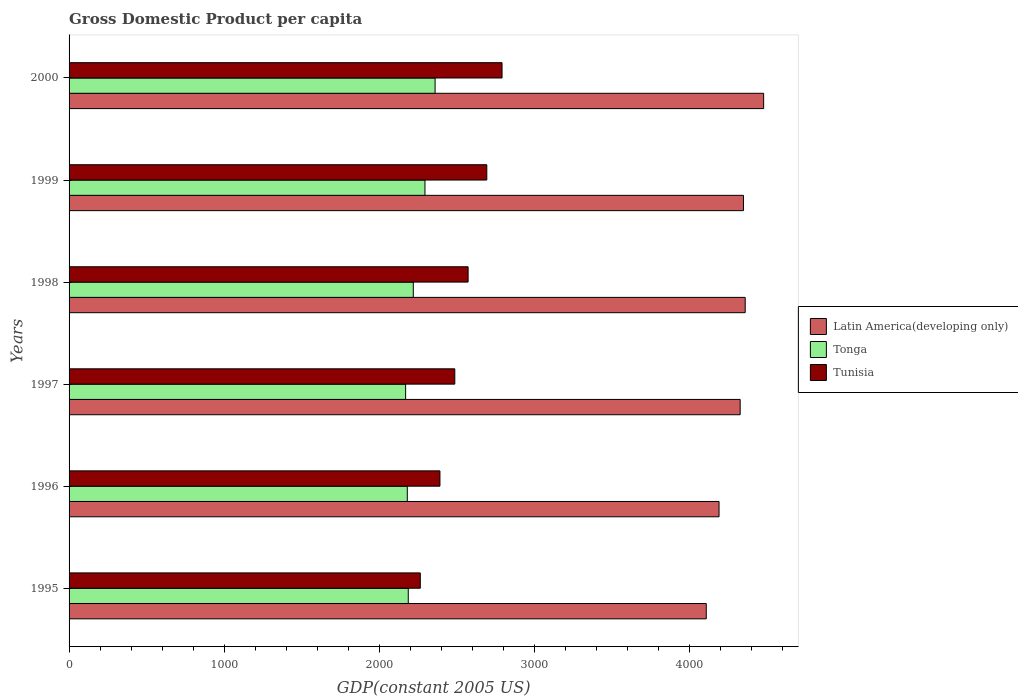How many groups of bars are there?
Give a very brief answer. 6. Are the number of bars on each tick of the Y-axis equal?
Offer a terse response. Yes. How many bars are there on the 4th tick from the top?
Provide a short and direct response. 3. In how many cases, is the number of bars for a given year not equal to the number of legend labels?
Make the answer very short. 0. What is the GDP per capita in Tunisia in 2000?
Your answer should be very brief. 2790.77. Across all years, what is the maximum GDP per capita in Latin America(developing only)?
Offer a very short reply. 4476.93. Across all years, what is the minimum GDP per capita in Tonga?
Give a very brief answer. 2169.26. What is the total GDP per capita in Latin America(developing only) in the graph?
Give a very brief answer. 2.58e+04. What is the difference between the GDP per capita in Tonga in 1996 and that in 1999?
Give a very brief answer. -113.94. What is the difference between the GDP per capita in Tonga in 1996 and the GDP per capita in Latin America(developing only) in 2000?
Provide a succinct answer. -2296.86. What is the average GDP per capita in Latin America(developing only) per year?
Your response must be concise. 4300.7. In the year 1997, what is the difference between the GDP per capita in Tunisia and GDP per capita in Tonga?
Provide a succinct answer. 316.95. What is the ratio of the GDP per capita in Latin America(developing only) in 1996 to that in 1997?
Your response must be concise. 0.97. Is the GDP per capita in Latin America(developing only) in 1997 less than that in 1998?
Ensure brevity in your answer.  Yes. What is the difference between the highest and the second highest GDP per capita in Tunisia?
Keep it short and to the point. 98.3. What is the difference between the highest and the lowest GDP per capita in Latin America(developing only)?
Your answer should be compact. 369.84. In how many years, is the GDP per capita in Tunisia greater than the average GDP per capita in Tunisia taken over all years?
Offer a terse response. 3. What does the 3rd bar from the top in 1997 represents?
Offer a very short reply. Latin America(developing only). What does the 2nd bar from the bottom in 1997 represents?
Provide a succinct answer. Tonga. How many bars are there?
Give a very brief answer. 18. What is the difference between two consecutive major ticks on the X-axis?
Give a very brief answer. 1000. Are the values on the major ticks of X-axis written in scientific E-notation?
Keep it short and to the point. No. How are the legend labels stacked?
Offer a terse response. Vertical. What is the title of the graph?
Provide a succinct answer. Gross Domestic Product per capita. What is the label or title of the X-axis?
Your answer should be compact. GDP(constant 2005 US). What is the label or title of the Y-axis?
Offer a terse response. Years. What is the GDP(constant 2005 US) in Latin America(developing only) in 1995?
Make the answer very short. 4107.09. What is the GDP(constant 2005 US) of Tonga in 1995?
Your answer should be very brief. 2186.32. What is the GDP(constant 2005 US) in Tunisia in 1995?
Provide a succinct answer. 2263.9. What is the GDP(constant 2005 US) in Latin America(developing only) in 1996?
Make the answer very short. 4189.51. What is the GDP(constant 2005 US) of Tonga in 1996?
Give a very brief answer. 2180.07. What is the GDP(constant 2005 US) of Tunisia in 1996?
Provide a short and direct response. 2390.5. What is the GDP(constant 2005 US) in Latin America(developing only) in 1997?
Make the answer very short. 4325.7. What is the GDP(constant 2005 US) of Tonga in 1997?
Provide a short and direct response. 2169.26. What is the GDP(constant 2005 US) in Tunisia in 1997?
Your response must be concise. 2486.21. What is the GDP(constant 2005 US) in Latin America(developing only) in 1998?
Provide a short and direct response. 4358.09. What is the GDP(constant 2005 US) in Tonga in 1998?
Your answer should be very brief. 2218.79. What is the GDP(constant 2005 US) in Tunisia in 1998?
Your answer should be compact. 2572.1. What is the GDP(constant 2005 US) of Latin America(developing only) in 1999?
Ensure brevity in your answer.  4346.88. What is the GDP(constant 2005 US) of Tonga in 1999?
Offer a terse response. 2294.01. What is the GDP(constant 2005 US) of Tunisia in 1999?
Offer a terse response. 2692.46. What is the GDP(constant 2005 US) in Latin America(developing only) in 2000?
Provide a short and direct response. 4476.93. What is the GDP(constant 2005 US) in Tonga in 2000?
Offer a very short reply. 2359.2. What is the GDP(constant 2005 US) of Tunisia in 2000?
Ensure brevity in your answer.  2790.77. Across all years, what is the maximum GDP(constant 2005 US) in Latin America(developing only)?
Ensure brevity in your answer.  4476.93. Across all years, what is the maximum GDP(constant 2005 US) of Tonga?
Your answer should be very brief. 2359.2. Across all years, what is the maximum GDP(constant 2005 US) in Tunisia?
Your response must be concise. 2790.77. Across all years, what is the minimum GDP(constant 2005 US) of Latin America(developing only)?
Ensure brevity in your answer.  4107.09. Across all years, what is the minimum GDP(constant 2005 US) in Tonga?
Your answer should be compact. 2169.26. Across all years, what is the minimum GDP(constant 2005 US) in Tunisia?
Offer a very short reply. 2263.9. What is the total GDP(constant 2005 US) of Latin America(developing only) in the graph?
Give a very brief answer. 2.58e+04. What is the total GDP(constant 2005 US) of Tonga in the graph?
Offer a very short reply. 1.34e+04. What is the total GDP(constant 2005 US) of Tunisia in the graph?
Provide a succinct answer. 1.52e+04. What is the difference between the GDP(constant 2005 US) of Latin America(developing only) in 1995 and that in 1996?
Give a very brief answer. -82.41. What is the difference between the GDP(constant 2005 US) in Tonga in 1995 and that in 1996?
Offer a very short reply. 6.26. What is the difference between the GDP(constant 2005 US) in Tunisia in 1995 and that in 1996?
Ensure brevity in your answer.  -126.61. What is the difference between the GDP(constant 2005 US) in Latin America(developing only) in 1995 and that in 1997?
Your answer should be very brief. -218.61. What is the difference between the GDP(constant 2005 US) of Tonga in 1995 and that in 1997?
Provide a short and direct response. 17.06. What is the difference between the GDP(constant 2005 US) of Tunisia in 1995 and that in 1997?
Make the answer very short. -222.32. What is the difference between the GDP(constant 2005 US) in Latin America(developing only) in 1995 and that in 1998?
Your response must be concise. -251. What is the difference between the GDP(constant 2005 US) of Tonga in 1995 and that in 1998?
Provide a short and direct response. -32.47. What is the difference between the GDP(constant 2005 US) of Tunisia in 1995 and that in 1998?
Offer a terse response. -308.2. What is the difference between the GDP(constant 2005 US) in Latin America(developing only) in 1995 and that in 1999?
Give a very brief answer. -239.78. What is the difference between the GDP(constant 2005 US) of Tonga in 1995 and that in 1999?
Make the answer very short. -107.68. What is the difference between the GDP(constant 2005 US) in Tunisia in 1995 and that in 1999?
Your response must be concise. -428.57. What is the difference between the GDP(constant 2005 US) of Latin America(developing only) in 1995 and that in 2000?
Ensure brevity in your answer.  -369.84. What is the difference between the GDP(constant 2005 US) of Tonga in 1995 and that in 2000?
Give a very brief answer. -172.88. What is the difference between the GDP(constant 2005 US) of Tunisia in 1995 and that in 2000?
Provide a succinct answer. -526.87. What is the difference between the GDP(constant 2005 US) of Latin America(developing only) in 1996 and that in 1997?
Keep it short and to the point. -136.19. What is the difference between the GDP(constant 2005 US) in Tonga in 1996 and that in 1997?
Your answer should be compact. 10.81. What is the difference between the GDP(constant 2005 US) of Tunisia in 1996 and that in 1997?
Make the answer very short. -95.71. What is the difference between the GDP(constant 2005 US) in Latin America(developing only) in 1996 and that in 1998?
Provide a succinct answer. -168.58. What is the difference between the GDP(constant 2005 US) in Tonga in 1996 and that in 1998?
Provide a succinct answer. -38.72. What is the difference between the GDP(constant 2005 US) in Tunisia in 1996 and that in 1998?
Give a very brief answer. -181.6. What is the difference between the GDP(constant 2005 US) in Latin America(developing only) in 1996 and that in 1999?
Your response must be concise. -157.37. What is the difference between the GDP(constant 2005 US) in Tonga in 1996 and that in 1999?
Offer a terse response. -113.94. What is the difference between the GDP(constant 2005 US) of Tunisia in 1996 and that in 1999?
Your answer should be compact. -301.96. What is the difference between the GDP(constant 2005 US) in Latin America(developing only) in 1996 and that in 2000?
Your answer should be compact. -287.43. What is the difference between the GDP(constant 2005 US) in Tonga in 1996 and that in 2000?
Make the answer very short. -179.13. What is the difference between the GDP(constant 2005 US) of Tunisia in 1996 and that in 2000?
Provide a succinct answer. -400.26. What is the difference between the GDP(constant 2005 US) in Latin America(developing only) in 1997 and that in 1998?
Give a very brief answer. -32.39. What is the difference between the GDP(constant 2005 US) in Tonga in 1997 and that in 1998?
Your answer should be very brief. -49.53. What is the difference between the GDP(constant 2005 US) of Tunisia in 1997 and that in 1998?
Provide a succinct answer. -85.89. What is the difference between the GDP(constant 2005 US) in Latin America(developing only) in 1997 and that in 1999?
Ensure brevity in your answer.  -21.17. What is the difference between the GDP(constant 2005 US) in Tonga in 1997 and that in 1999?
Your answer should be very brief. -124.75. What is the difference between the GDP(constant 2005 US) of Tunisia in 1997 and that in 1999?
Provide a succinct answer. -206.25. What is the difference between the GDP(constant 2005 US) of Latin America(developing only) in 1997 and that in 2000?
Offer a terse response. -151.23. What is the difference between the GDP(constant 2005 US) of Tonga in 1997 and that in 2000?
Keep it short and to the point. -189.94. What is the difference between the GDP(constant 2005 US) of Tunisia in 1997 and that in 2000?
Offer a terse response. -304.55. What is the difference between the GDP(constant 2005 US) in Latin America(developing only) in 1998 and that in 1999?
Offer a terse response. 11.21. What is the difference between the GDP(constant 2005 US) in Tonga in 1998 and that in 1999?
Keep it short and to the point. -75.22. What is the difference between the GDP(constant 2005 US) in Tunisia in 1998 and that in 1999?
Provide a succinct answer. -120.36. What is the difference between the GDP(constant 2005 US) in Latin America(developing only) in 1998 and that in 2000?
Make the answer very short. -118.85. What is the difference between the GDP(constant 2005 US) in Tonga in 1998 and that in 2000?
Your answer should be compact. -140.41. What is the difference between the GDP(constant 2005 US) in Tunisia in 1998 and that in 2000?
Ensure brevity in your answer.  -218.66. What is the difference between the GDP(constant 2005 US) in Latin America(developing only) in 1999 and that in 2000?
Your answer should be compact. -130.06. What is the difference between the GDP(constant 2005 US) in Tonga in 1999 and that in 2000?
Keep it short and to the point. -65.19. What is the difference between the GDP(constant 2005 US) of Tunisia in 1999 and that in 2000?
Your answer should be very brief. -98.3. What is the difference between the GDP(constant 2005 US) of Latin America(developing only) in 1995 and the GDP(constant 2005 US) of Tonga in 1996?
Your response must be concise. 1927.02. What is the difference between the GDP(constant 2005 US) in Latin America(developing only) in 1995 and the GDP(constant 2005 US) in Tunisia in 1996?
Your answer should be very brief. 1716.59. What is the difference between the GDP(constant 2005 US) in Tonga in 1995 and the GDP(constant 2005 US) in Tunisia in 1996?
Provide a short and direct response. -204.18. What is the difference between the GDP(constant 2005 US) in Latin America(developing only) in 1995 and the GDP(constant 2005 US) in Tonga in 1997?
Make the answer very short. 1937.83. What is the difference between the GDP(constant 2005 US) in Latin America(developing only) in 1995 and the GDP(constant 2005 US) in Tunisia in 1997?
Provide a succinct answer. 1620.88. What is the difference between the GDP(constant 2005 US) in Tonga in 1995 and the GDP(constant 2005 US) in Tunisia in 1997?
Make the answer very short. -299.89. What is the difference between the GDP(constant 2005 US) of Latin America(developing only) in 1995 and the GDP(constant 2005 US) of Tonga in 1998?
Offer a terse response. 1888.3. What is the difference between the GDP(constant 2005 US) in Latin America(developing only) in 1995 and the GDP(constant 2005 US) in Tunisia in 1998?
Offer a terse response. 1534.99. What is the difference between the GDP(constant 2005 US) in Tonga in 1995 and the GDP(constant 2005 US) in Tunisia in 1998?
Your answer should be compact. -385.78. What is the difference between the GDP(constant 2005 US) of Latin America(developing only) in 1995 and the GDP(constant 2005 US) of Tonga in 1999?
Your answer should be compact. 1813.08. What is the difference between the GDP(constant 2005 US) in Latin America(developing only) in 1995 and the GDP(constant 2005 US) in Tunisia in 1999?
Your answer should be compact. 1414.63. What is the difference between the GDP(constant 2005 US) of Tonga in 1995 and the GDP(constant 2005 US) of Tunisia in 1999?
Provide a succinct answer. -506.14. What is the difference between the GDP(constant 2005 US) of Latin America(developing only) in 1995 and the GDP(constant 2005 US) of Tonga in 2000?
Your answer should be compact. 1747.89. What is the difference between the GDP(constant 2005 US) of Latin America(developing only) in 1995 and the GDP(constant 2005 US) of Tunisia in 2000?
Offer a very short reply. 1316.33. What is the difference between the GDP(constant 2005 US) of Tonga in 1995 and the GDP(constant 2005 US) of Tunisia in 2000?
Offer a terse response. -604.44. What is the difference between the GDP(constant 2005 US) in Latin America(developing only) in 1996 and the GDP(constant 2005 US) in Tonga in 1997?
Provide a succinct answer. 2020.25. What is the difference between the GDP(constant 2005 US) in Latin America(developing only) in 1996 and the GDP(constant 2005 US) in Tunisia in 1997?
Provide a short and direct response. 1703.29. What is the difference between the GDP(constant 2005 US) in Tonga in 1996 and the GDP(constant 2005 US) in Tunisia in 1997?
Offer a very short reply. -306.15. What is the difference between the GDP(constant 2005 US) in Latin America(developing only) in 1996 and the GDP(constant 2005 US) in Tonga in 1998?
Your answer should be compact. 1970.72. What is the difference between the GDP(constant 2005 US) in Latin America(developing only) in 1996 and the GDP(constant 2005 US) in Tunisia in 1998?
Provide a succinct answer. 1617.41. What is the difference between the GDP(constant 2005 US) in Tonga in 1996 and the GDP(constant 2005 US) in Tunisia in 1998?
Keep it short and to the point. -392.03. What is the difference between the GDP(constant 2005 US) in Latin America(developing only) in 1996 and the GDP(constant 2005 US) in Tonga in 1999?
Your answer should be compact. 1895.5. What is the difference between the GDP(constant 2005 US) of Latin America(developing only) in 1996 and the GDP(constant 2005 US) of Tunisia in 1999?
Keep it short and to the point. 1497.04. What is the difference between the GDP(constant 2005 US) of Tonga in 1996 and the GDP(constant 2005 US) of Tunisia in 1999?
Provide a short and direct response. -512.4. What is the difference between the GDP(constant 2005 US) in Latin America(developing only) in 1996 and the GDP(constant 2005 US) in Tonga in 2000?
Ensure brevity in your answer.  1830.31. What is the difference between the GDP(constant 2005 US) of Latin America(developing only) in 1996 and the GDP(constant 2005 US) of Tunisia in 2000?
Provide a short and direct response. 1398.74. What is the difference between the GDP(constant 2005 US) in Tonga in 1996 and the GDP(constant 2005 US) in Tunisia in 2000?
Offer a terse response. -610.7. What is the difference between the GDP(constant 2005 US) in Latin America(developing only) in 1997 and the GDP(constant 2005 US) in Tonga in 1998?
Offer a terse response. 2106.91. What is the difference between the GDP(constant 2005 US) of Latin America(developing only) in 1997 and the GDP(constant 2005 US) of Tunisia in 1998?
Provide a short and direct response. 1753.6. What is the difference between the GDP(constant 2005 US) in Tonga in 1997 and the GDP(constant 2005 US) in Tunisia in 1998?
Ensure brevity in your answer.  -402.84. What is the difference between the GDP(constant 2005 US) in Latin America(developing only) in 1997 and the GDP(constant 2005 US) in Tonga in 1999?
Make the answer very short. 2031.69. What is the difference between the GDP(constant 2005 US) of Latin America(developing only) in 1997 and the GDP(constant 2005 US) of Tunisia in 1999?
Offer a very short reply. 1633.24. What is the difference between the GDP(constant 2005 US) in Tonga in 1997 and the GDP(constant 2005 US) in Tunisia in 1999?
Offer a terse response. -523.2. What is the difference between the GDP(constant 2005 US) in Latin America(developing only) in 1997 and the GDP(constant 2005 US) in Tonga in 2000?
Give a very brief answer. 1966.5. What is the difference between the GDP(constant 2005 US) in Latin America(developing only) in 1997 and the GDP(constant 2005 US) in Tunisia in 2000?
Give a very brief answer. 1534.94. What is the difference between the GDP(constant 2005 US) in Tonga in 1997 and the GDP(constant 2005 US) in Tunisia in 2000?
Your answer should be compact. -621.51. What is the difference between the GDP(constant 2005 US) of Latin America(developing only) in 1998 and the GDP(constant 2005 US) of Tonga in 1999?
Your response must be concise. 2064.08. What is the difference between the GDP(constant 2005 US) in Latin America(developing only) in 1998 and the GDP(constant 2005 US) in Tunisia in 1999?
Provide a succinct answer. 1665.62. What is the difference between the GDP(constant 2005 US) of Tonga in 1998 and the GDP(constant 2005 US) of Tunisia in 1999?
Offer a very short reply. -473.67. What is the difference between the GDP(constant 2005 US) in Latin America(developing only) in 1998 and the GDP(constant 2005 US) in Tonga in 2000?
Your answer should be very brief. 1998.89. What is the difference between the GDP(constant 2005 US) of Latin America(developing only) in 1998 and the GDP(constant 2005 US) of Tunisia in 2000?
Ensure brevity in your answer.  1567.32. What is the difference between the GDP(constant 2005 US) in Tonga in 1998 and the GDP(constant 2005 US) in Tunisia in 2000?
Make the answer very short. -571.97. What is the difference between the GDP(constant 2005 US) in Latin America(developing only) in 1999 and the GDP(constant 2005 US) in Tonga in 2000?
Offer a terse response. 1987.67. What is the difference between the GDP(constant 2005 US) in Latin America(developing only) in 1999 and the GDP(constant 2005 US) in Tunisia in 2000?
Keep it short and to the point. 1556.11. What is the difference between the GDP(constant 2005 US) in Tonga in 1999 and the GDP(constant 2005 US) in Tunisia in 2000?
Your answer should be compact. -496.76. What is the average GDP(constant 2005 US) in Latin America(developing only) per year?
Your answer should be compact. 4300.7. What is the average GDP(constant 2005 US) of Tonga per year?
Provide a short and direct response. 2234.61. What is the average GDP(constant 2005 US) in Tunisia per year?
Provide a short and direct response. 2532.66. In the year 1995, what is the difference between the GDP(constant 2005 US) of Latin America(developing only) and GDP(constant 2005 US) of Tonga?
Your answer should be compact. 1920.77. In the year 1995, what is the difference between the GDP(constant 2005 US) in Latin America(developing only) and GDP(constant 2005 US) in Tunisia?
Ensure brevity in your answer.  1843.19. In the year 1995, what is the difference between the GDP(constant 2005 US) of Tonga and GDP(constant 2005 US) of Tunisia?
Give a very brief answer. -77.57. In the year 1996, what is the difference between the GDP(constant 2005 US) of Latin America(developing only) and GDP(constant 2005 US) of Tonga?
Keep it short and to the point. 2009.44. In the year 1996, what is the difference between the GDP(constant 2005 US) in Latin America(developing only) and GDP(constant 2005 US) in Tunisia?
Keep it short and to the point. 1799. In the year 1996, what is the difference between the GDP(constant 2005 US) of Tonga and GDP(constant 2005 US) of Tunisia?
Ensure brevity in your answer.  -210.44. In the year 1997, what is the difference between the GDP(constant 2005 US) of Latin America(developing only) and GDP(constant 2005 US) of Tonga?
Keep it short and to the point. 2156.44. In the year 1997, what is the difference between the GDP(constant 2005 US) in Latin America(developing only) and GDP(constant 2005 US) in Tunisia?
Ensure brevity in your answer.  1839.49. In the year 1997, what is the difference between the GDP(constant 2005 US) in Tonga and GDP(constant 2005 US) in Tunisia?
Your answer should be compact. -316.95. In the year 1998, what is the difference between the GDP(constant 2005 US) of Latin America(developing only) and GDP(constant 2005 US) of Tonga?
Your response must be concise. 2139.3. In the year 1998, what is the difference between the GDP(constant 2005 US) of Latin America(developing only) and GDP(constant 2005 US) of Tunisia?
Your answer should be compact. 1785.99. In the year 1998, what is the difference between the GDP(constant 2005 US) in Tonga and GDP(constant 2005 US) in Tunisia?
Your response must be concise. -353.31. In the year 1999, what is the difference between the GDP(constant 2005 US) of Latin America(developing only) and GDP(constant 2005 US) of Tonga?
Keep it short and to the point. 2052.87. In the year 1999, what is the difference between the GDP(constant 2005 US) in Latin America(developing only) and GDP(constant 2005 US) in Tunisia?
Your answer should be very brief. 1654.41. In the year 1999, what is the difference between the GDP(constant 2005 US) of Tonga and GDP(constant 2005 US) of Tunisia?
Give a very brief answer. -398.46. In the year 2000, what is the difference between the GDP(constant 2005 US) in Latin America(developing only) and GDP(constant 2005 US) in Tonga?
Your answer should be very brief. 2117.73. In the year 2000, what is the difference between the GDP(constant 2005 US) of Latin America(developing only) and GDP(constant 2005 US) of Tunisia?
Provide a short and direct response. 1686.17. In the year 2000, what is the difference between the GDP(constant 2005 US) in Tonga and GDP(constant 2005 US) in Tunisia?
Your answer should be very brief. -431.56. What is the ratio of the GDP(constant 2005 US) in Latin America(developing only) in 1995 to that in 1996?
Provide a short and direct response. 0.98. What is the ratio of the GDP(constant 2005 US) in Tunisia in 1995 to that in 1996?
Offer a very short reply. 0.95. What is the ratio of the GDP(constant 2005 US) of Latin America(developing only) in 1995 to that in 1997?
Your answer should be compact. 0.95. What is the ratio of the GDP(constant 2005 US) of Tonga in 1995 to that in 1997?
Offer a very short reply. 1.01. What is the ratio of the GDP(constant 2005 US) of Tunisia in 1995 to that in 1997?
Provide a succinct answer. 0.91. What is the ratio of the GDP(constant 2005 US) in Latin America(developing only) in 1995 to that in 1998?
Give a very brief answer. 0.94. What is the ratio of the GDP(constant 2005 US) of Tonga in 1995 to that in 1998?
Your answer should be compact. 0.99. What is the ratio of the GDP(constant 2005 US) of Tunisia in 1995 to that in 1998?
Keep it short and to the point. 0.88. What is the ratio of the GDP(constant 2005 US) in Latin America(developing only) in 1995 to that in 1999?
Provide a succinct answer. 0.94. What is the ratio of the GDP(constant 2005 US) of Tonga in 1995 to that in 1999?
Provide a succinct answer. 0.95. What is the ratio of the GDP(constant 2005 US) of Tunisia in 1995 to that in 1999?
Make the answer very short. 0.84. What is the ratio of the GDP(constant 2005 US) in Latin America(developing only) in 1995 to that in 2000?
Give a very brief answer. 0.92. What is the ratio of the GDP(constant 2005 US) in Tonga in 1995 to that in 2000?
Ensure brevity in your answer.  0.93. What is the ratio of the GDP(constant 2005 US) in Tunisia in 1995 to that in 2000?
Your response must be concise. 0.81. What is the ratio of the GDP(constant 2005 US) in Latin America(developing only) in 1996 to that in 1997?
Ensure brevity in your answer.  0.97. What is the ratio of the GDP(constant 2005 US) of Tunisia in 1996 to that in 1997?
Offer a very short reply. 0.96. What is the ratio of the GDP(constant 2005 US) in Latin America(developing only) in 1996 to that in 1998?
Offer a terse response. 0.96. What is the ratio of the GDP(constant 2005 US) of Tonga in 1996 to that in 1998?
Give a very brief answer. 0.98. What is the ratio of the GDP(constant 2005 US) of Tunisia in 1996 to that in 1998?
Your answer should be compact. 0.93. What is the ratio of the GDP(constant 2005 US) in Latin America(developing only) in 1996 to that in 1999?
Make the answer very short. 0.96. What is the ratio of the GDP(constant 2005 US) of Tonga in 1996 to that in 1999?
Offer a terse response. 0.95. What is the ratio of the GDP(constant 2005 US) in Tunisia in 1996 to that in 1999?
Your answer should be compact. 0.89. What is the ratio of the GDP(constant 2005 US) of Latin America(developing only) in 1996 to that in 2000?
Keep it short and to the point. 0.94. What is the ratio of the GDP(constant 2005 US) in Tonga in 1996 to that in 2000?
Offer a terse response. 0.92. What is the ratio of the GDP(constant 2005 US) of Tunisia in 1996 to that in 2000?
Ensure brevity in your answer.  0.86. What is the ratio of the GDP(constant 2005 US) in Tonga in 1997 to that in 1998?
Your answer should be very brief. 0.98. What is the ratio of the GDP(constant 2005 US) in Tunisia in 1997 to that in 1998?
Offer a terse response. 0.97. What is the ratio of the GDP(constant 2005 US) in Tonga in 1997 to that in 1999?
Your answer should be very brief. 0.95. What is the ratio of the GDP(constant 2005 US) in Tunisia in 1997 to that in 1999?
Your answer should be compact. 0.92. What is the ratio of the GDP(constant 2005 US) in Latin America(developing only) in 1997 to that in 2000?
Your answer should be compact. 0.97. What is the ratio of the GDP(constant 2005 US) in Tonga in 1997 to that in 2000?
Make the answer very short. 0.92. What is the ratio of the GDP(constant 2005 US) of Tunisia in 1997 to that in 2000?
Provide a short and direct response. 0.89. What is the ratio of the GDP(constant 2005 US) in Tonga in 1998 to that in 1999?
Provide a succinct answer. 0.97. What is the ratio of the GDP(constant 2005 US) of Tunisia in 1998 to that in 1999?
Give a very brief answer. 0.96. What is the ratio of the GDP(constant 2005 US) of Latin America(developing only) in 1998 to that in 2000?
Keep it short and to the point. 0.97. What is the ratio of the GDP(constant 2005 US) in Tonga in 1998 to that in 2000?
Make the answer very short. 0.94. What is the ratio of the GDP(constant 2005 US) of Tunisia in 1998 to that in 2000?
Your answer should be compact. 0.92. What is the ratio of the GDP(constant 2005 US) of Latin America(developing only) in 1999 to that in 2000?
Ensure brevity in your answer.  0.97. What is the ratio of the GDP(constant 2005 US) in Tonga in 1999 to that in 2000?
Offer a terse response. 0.97. What is the ratio of the GDP(constant 2005 US) in Tunisia in 1999 to that in 2000?
Keep it short and to the point. 0.96. What is the difference between the highest and the second highest GDP(constant 2005 US) of Latin America(developing only)?
Your response must be concise. 118.85. What is the difference between the highest and the second highest GDP(constant 2005 US) in Tonga?
Ensure brevity in your answer.  65.19. What is the difference between the highest and the second highest GDP(constant 2005 US) in Tunisia?
Your response must be concise. 98.3. What is the difference between the highest and the lowest GDP(constant 2005 US) of Latin America(developing only)?
Make the answer very short. 369.84. What is the difference between the highest and the lowest GDP(constant 2005 US) in Tonga?
Give a very brief answer. 189.94. What is the difference between the highest and the lowest GDP(constant 2005 US) in Tunisia?
Your answer should be very brief. 526.87. 